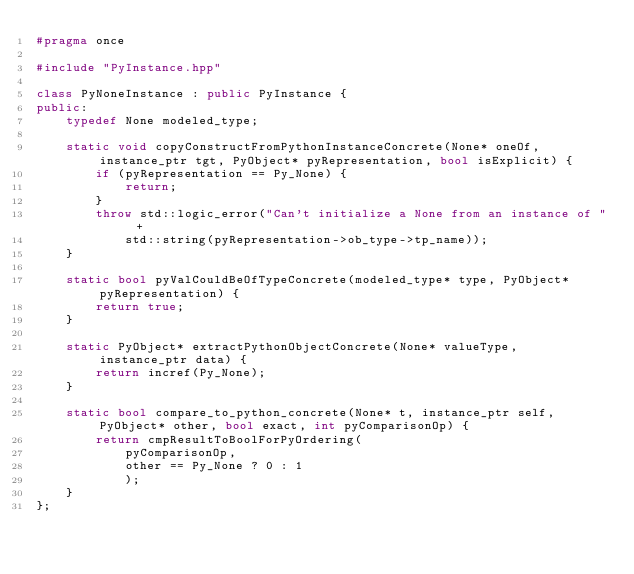<code> <loc_0><loc_0><loc_500><loc_500><_C++_>#pragma once

#include "PyInstance.hpp"

class PyNoneInstance : public PyInstance {
public:
    typedef None modeled_type;

    static void copyConstructFromPythonInstanceConcrete(None* oneOf, instance_ptr tgt, PyObject* pyRepresentation, bool isExplicit) {
        if (pyRepresentation == Py_None) {
            return;
        }
        throw std::logic_error("Can't initialize a None from an instance of " +
            std::string(pyRepresentation->ob_type->tp_name));
    }

    static bool pyValCouldBeOfTypeConcrete(modeled_type* type, PyObject* pyRepresentation) {
        return true;
    }

    static PyObject* extractPythonObjectConcrete(None* valueType, instance_ptr data) {
        return incref(Py_None);
    }

    static bool compare_to_python_concrete(None* t, instance_ptr self, PyObject* other, bool exact, int pyComparisonOp) {
        return cmpResultToBoolForPyOrdering(
            pyComparisonOp,
            other == Py_None ? 0 : 1
            );
    }
};

</code> 